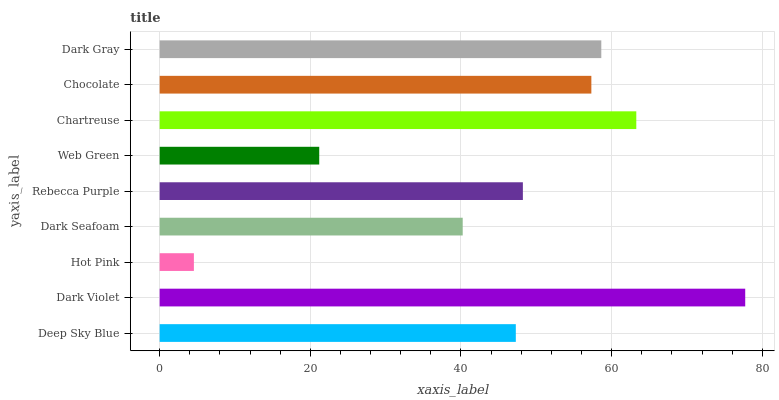Is Hot Pink the minimum?
Answer yes or no. Yes. Is Dark Violet the maximum?
Answer yes or no. Yes. Is Dark Violet the minimum?
Answer yes or no. No. Is Hot Pink the maximum?
Answer yes or no. No. Is Dark Violet greater than Hot Pink?
Answer yes or no. Yes. Is Hot Pink less than Dark Violet?
Answer yes or no. Yes. Is Hot Pink greater than Dark Violet?
Answer yes or no. No. Is Dark Violet less than Hot Pink?
Answer yes or no. No. Is Rebecca Purple the high median?
Answer yes or no. Yes. Is Rebecca Purple the low median?
Answer yes or no. Yes. Is Chocolate the high median?
Answer yes or no. No. Is Chocolate the low median?
Answer yes or no. No. 